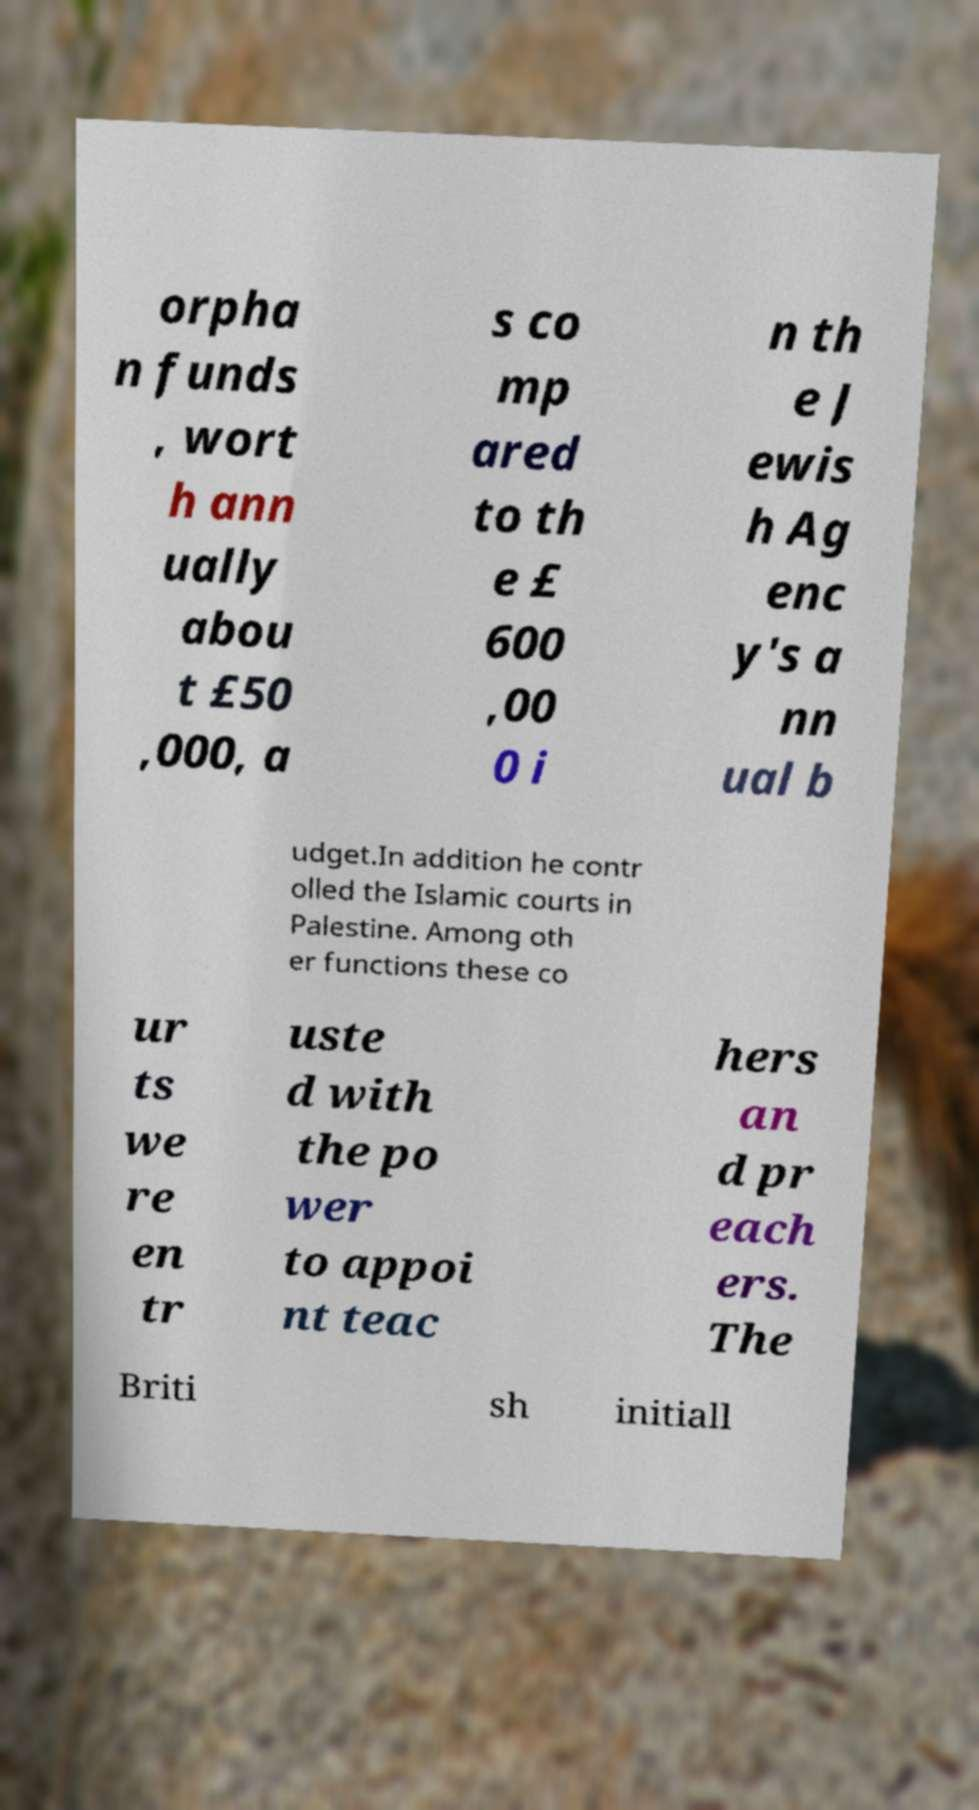Could you assist in decoding the text presented in this image and type it out clearly? orpha n funds , wort h ann ually abou t £50 ,000, a s co mp ared to th e £ 600 ,00 0 i n th e J ewis h Ag enc y's a nn ual b udget.In addition he contr olled the Islamic courts in Palestine. Among oth er functions these co ur ts we re en tr uste d with the po wer to appoi nt teac hers an d pr each ers. The Briti sh initiall 